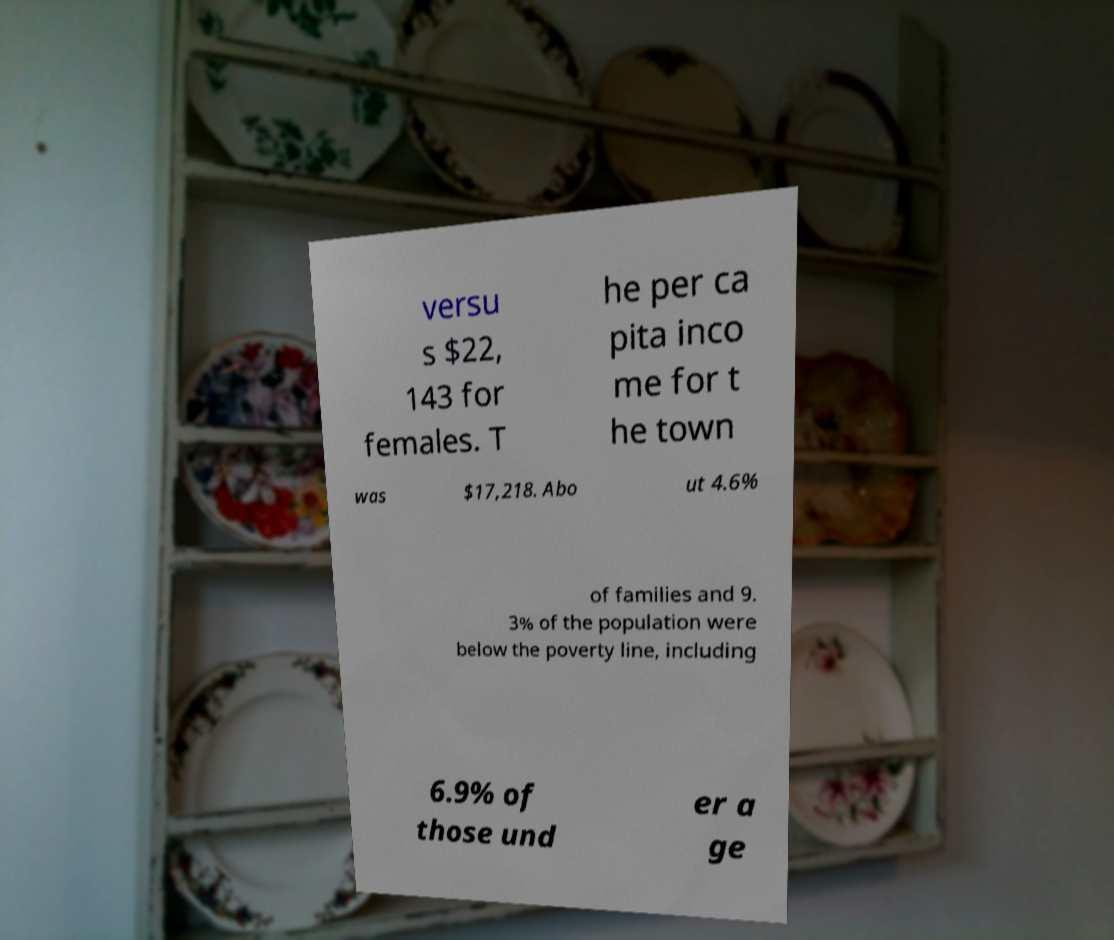I need the written content from this picture converted into text. Can you do that? versu s $22, 143 for females. T he per ca pita inco me for t he town was $17,218. Abo ut 4.6% of families and 9. 3% of the population were below the poverty line, including 6.9% of those und er a ge 